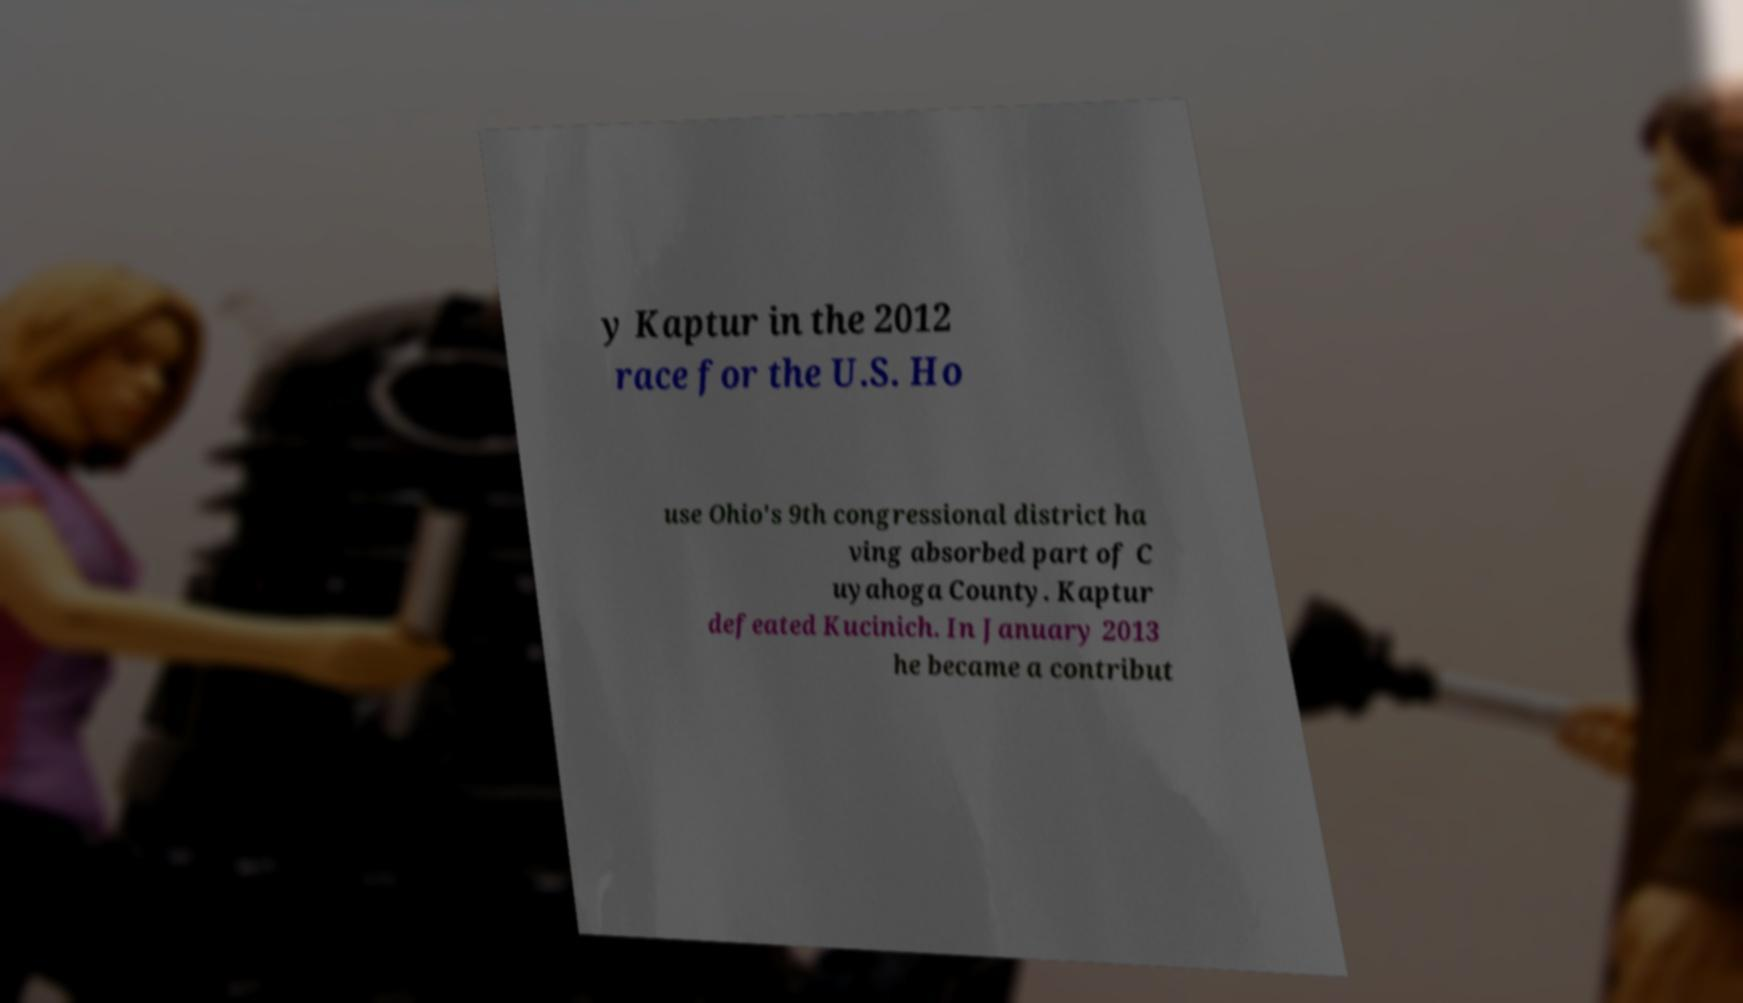Please identify and transcribe the text found in this image. y Kaptur in the 2012 race for the U.S. Ho use Ohio's 9th congressional district ha ving absorbed part of C uyahoga County. Kaptur defeated Kucinich. In January 2013 he became a contribut 